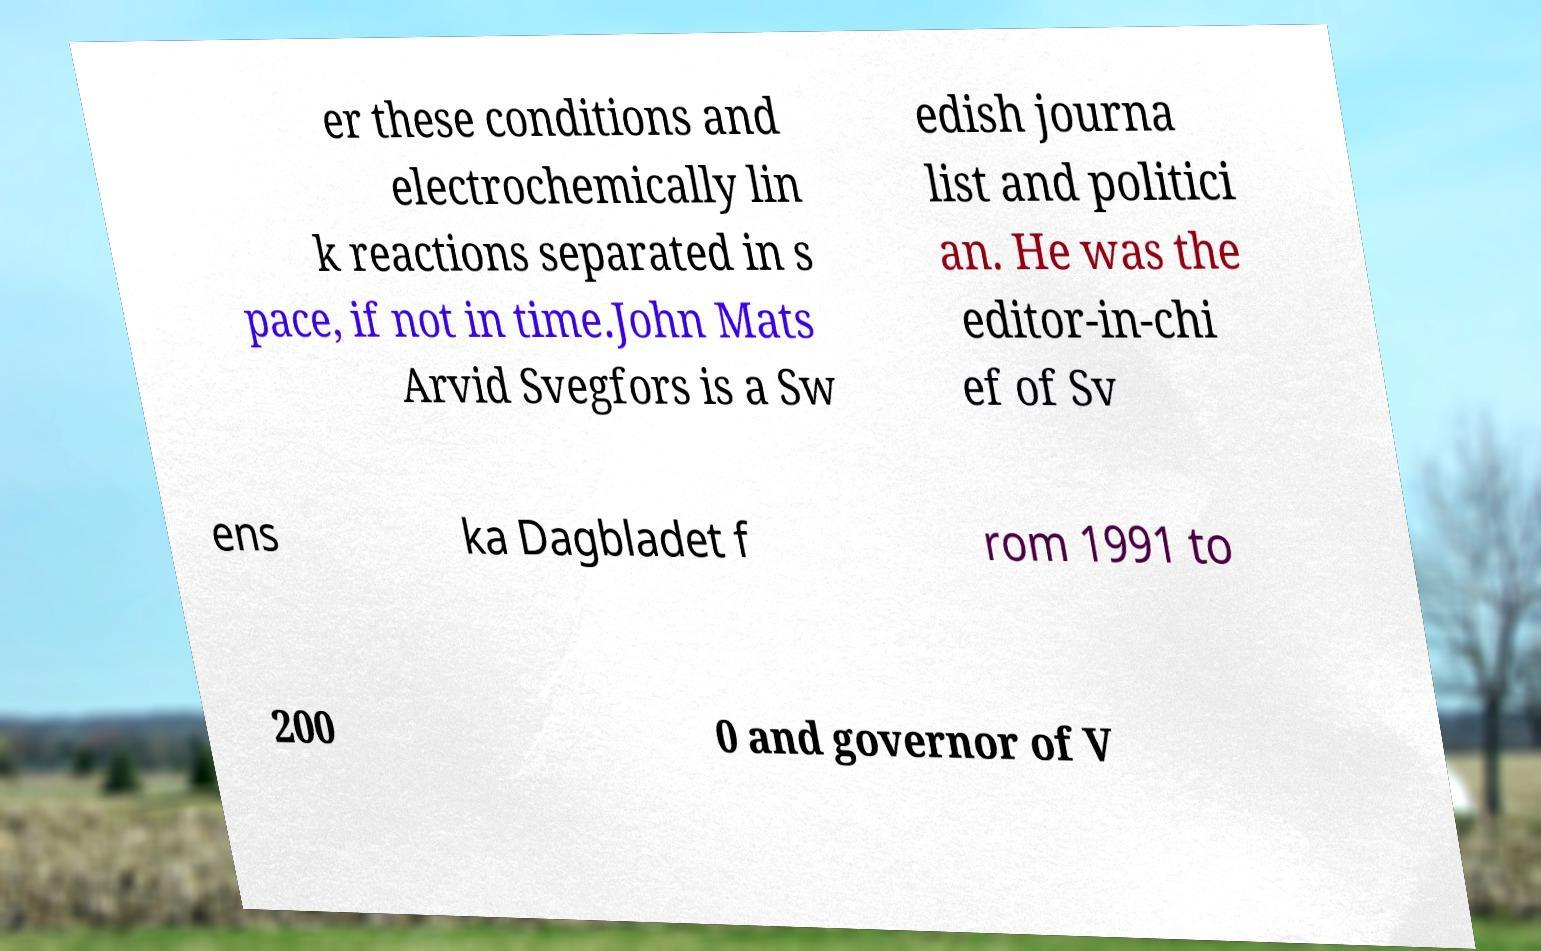Please identify and transcribe the text found in this image. er these conditions and electrochemically lin k reactions separated in s pace, if not in time.John Mats Arvid Svegfors is a Sw edish journa list and politici an. He was the editor-in-chi ef of Sv ens ka Dagbladet f rom 1991 to 200 0 and governor of V 